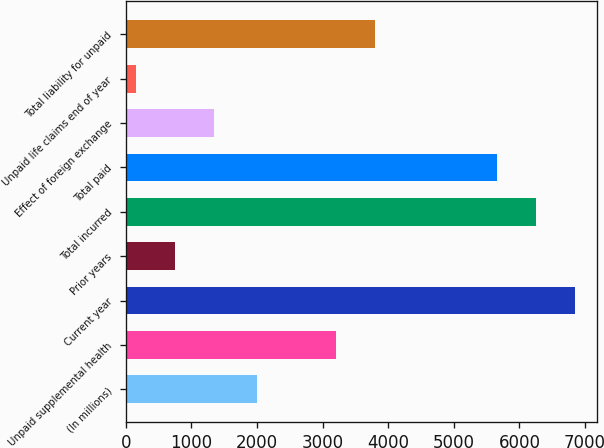<chart> <loc_0><loc_0><loc_500><loc_500><bar_chart><fcel>(In millions)<fcel>Unpaid supplemental health<fcel>Current year<fcel>Prior years<fcel>Total incurred<fcel>Total paid<fcel>Effect of foreign exchange<fcel>Unpaid life claims end of year<fcel>Total liability for unpaid<nl><fcel>2008<fcel>3201.6<fcel>6846.6<fcel>755.8<fcel>6249.8<fcel>5653<fcel>1352.6<fcel>159<fcel>3798.4<nl></chart> 